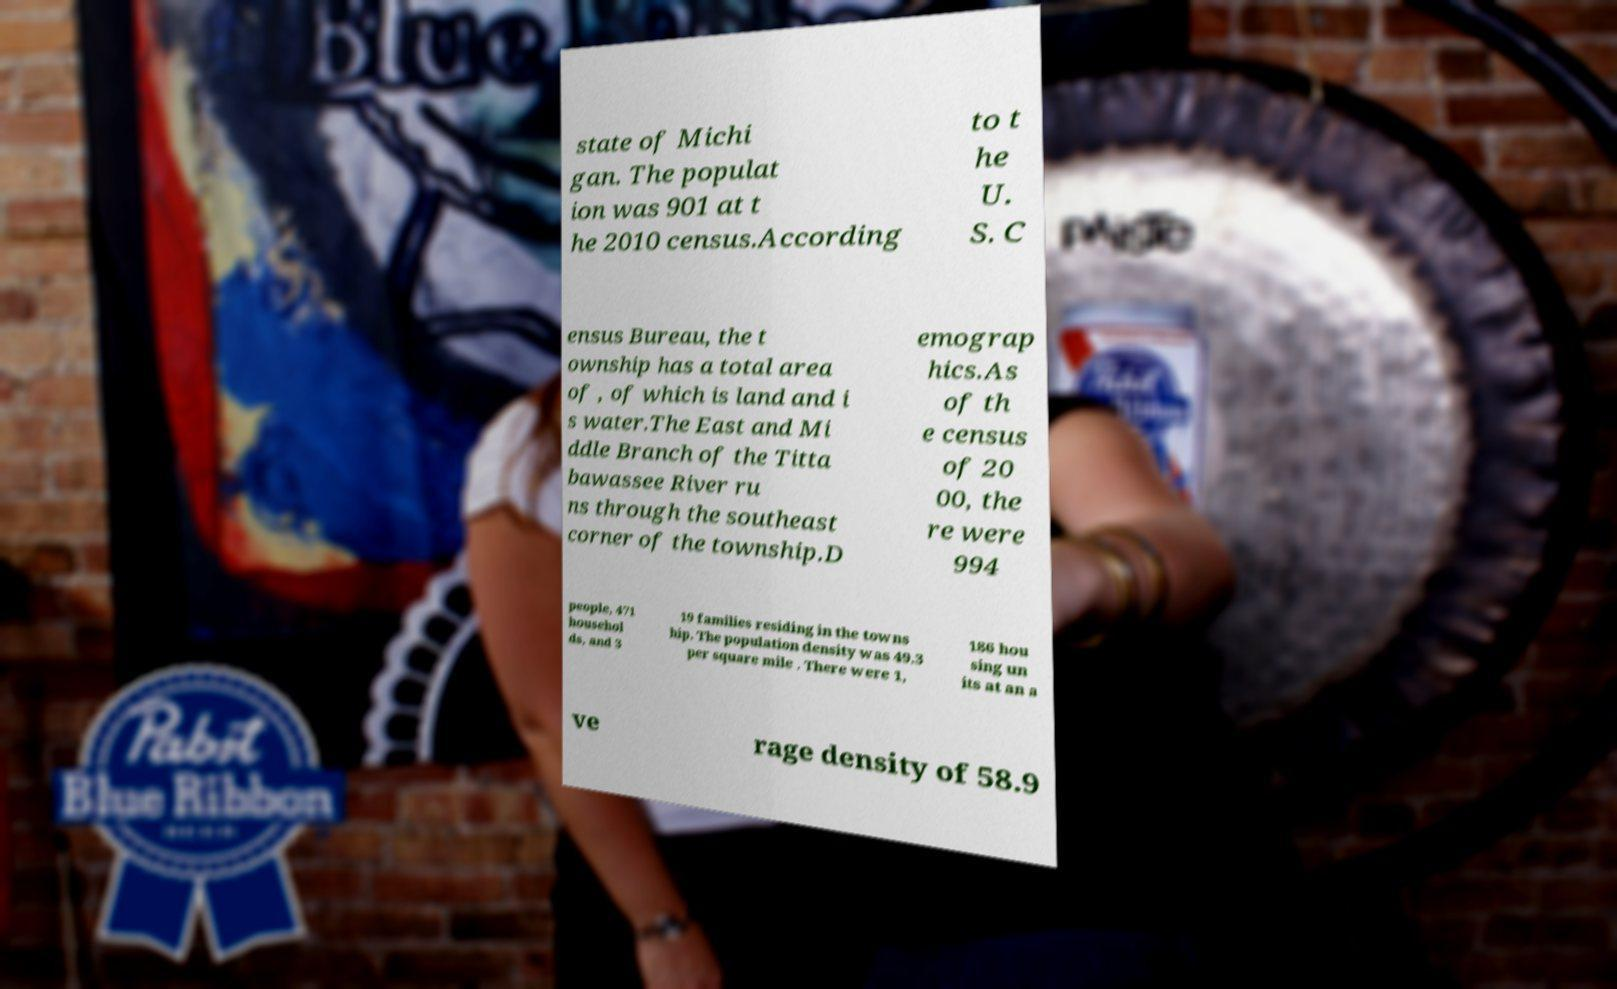Could you extract and type out the text from this image? state of Michi gan. The populat ion was 901 at t he 2010 census.According to t he U. S. C ensus Bureau, the t ownship has a total area of , of which is land and i s water.The East and Mi ddle Branch of the Titta bawassee River ru ns through the southeast corner of the township.D emograp hics.As of th e census of 20 00, the re were 994 people, 471 househol ds, and 3 19 families residing in the towns hip. The population density was 49.3 per square mile . There were 1, 186 hou sing un its at an a ve rage density of 58.9 